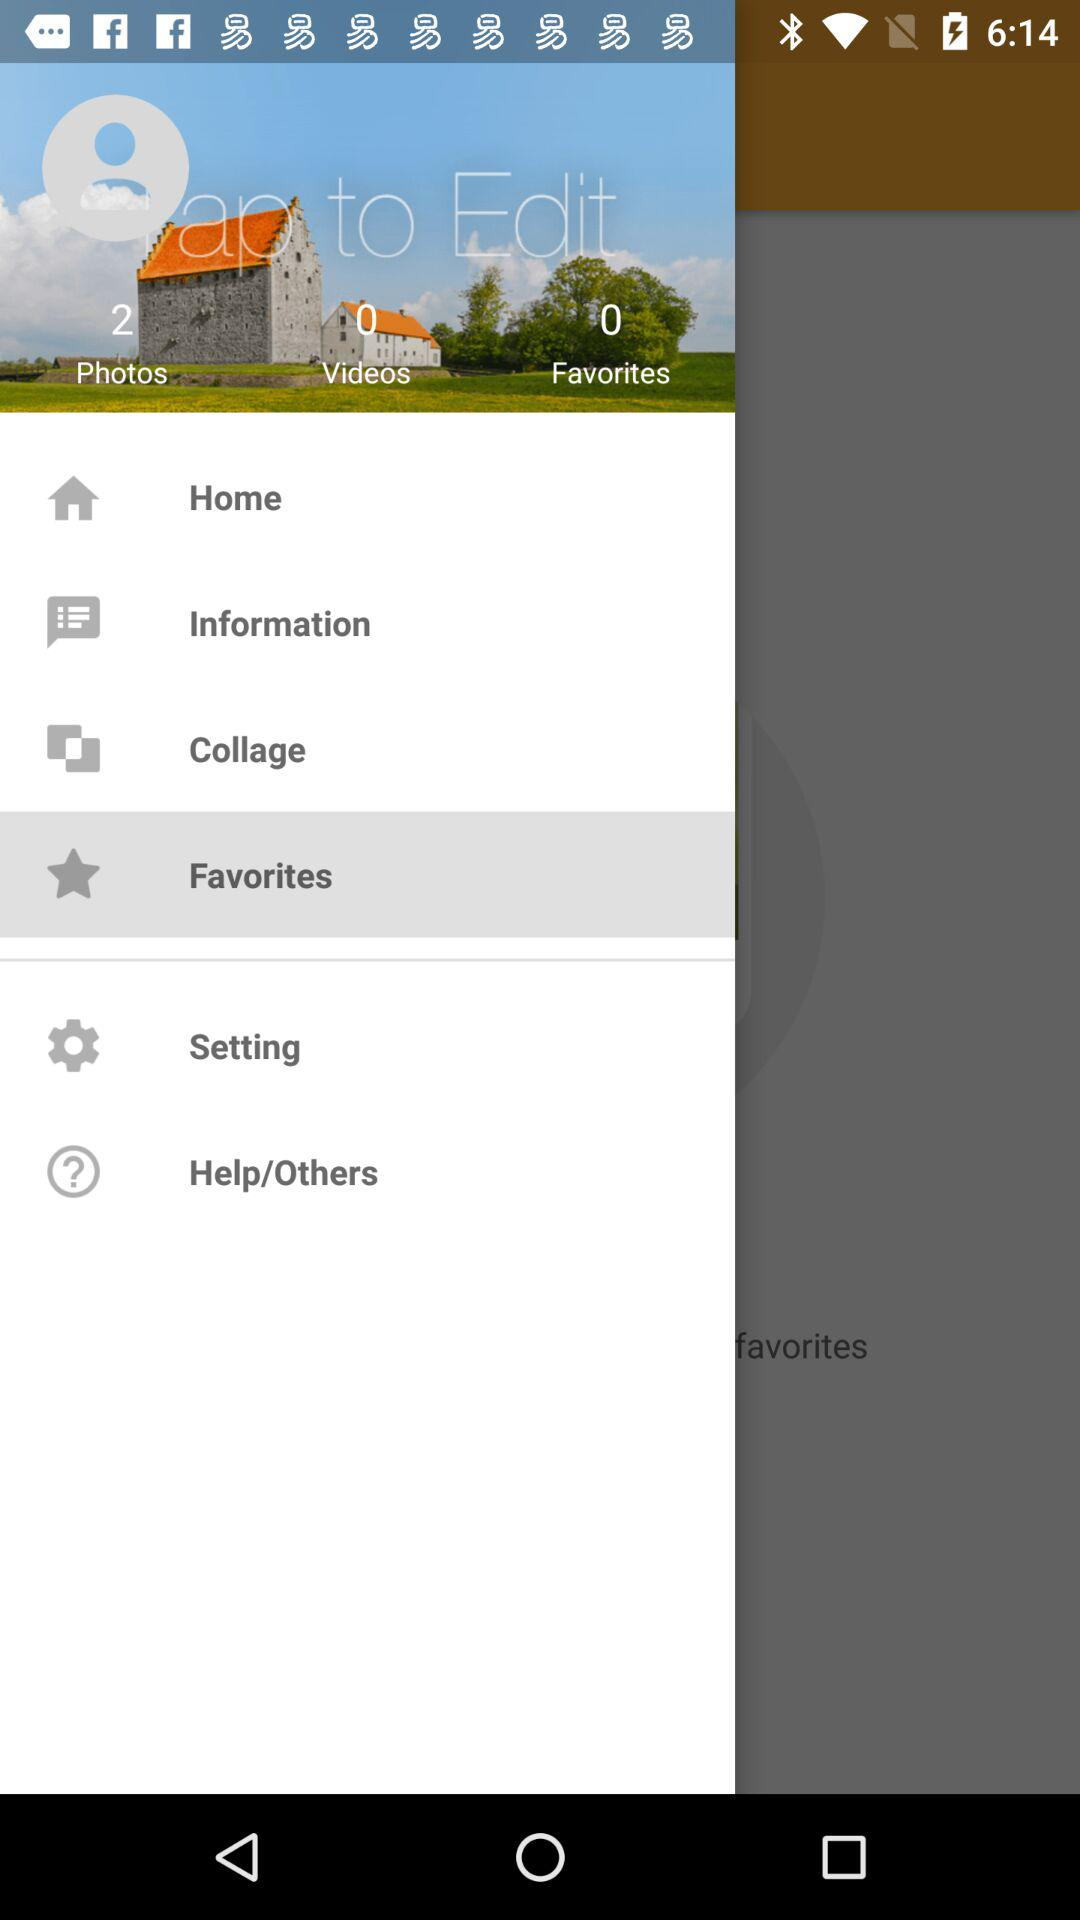How many photos are there? There are 2 photos. 